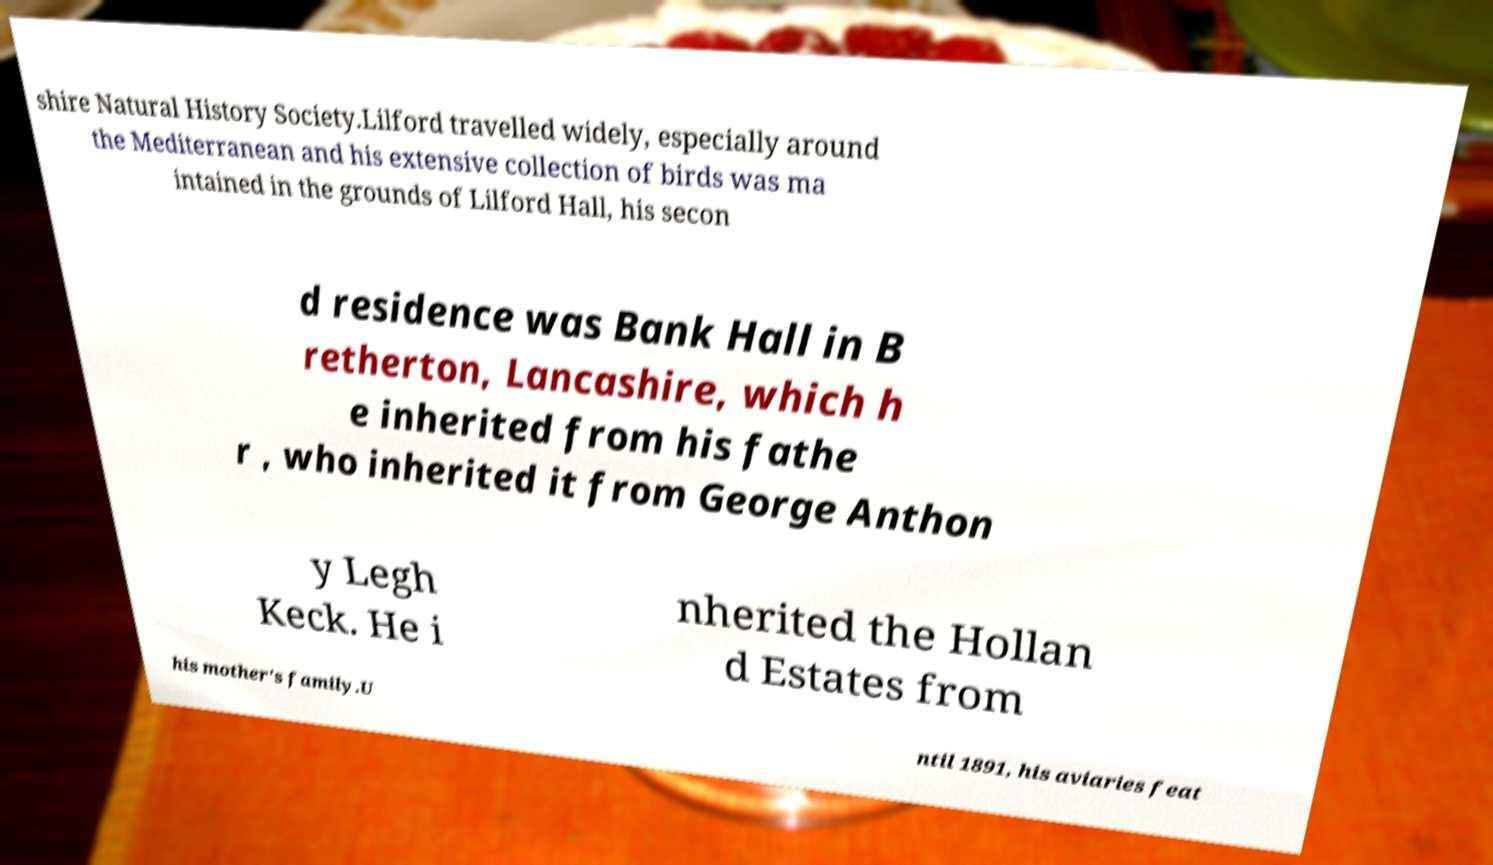Please read and relay the text visible in this image. What does it say? shire Natural History Society.Lilford travelled widely, especially around the Mediterranean and his extensive collection of birds was ma intained in the grounds of Lilford Hall, his secon d residence was Bank Hall in B retherton, Lancashire, which h e inherited from his fathe r , who inherited it from George Anthon y Legh Keck. He i nherited the Hollan d Estates from his mother's family.U ntil 1891, his aviaries feat 